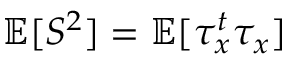Convert formula to latex. <formula><loc_0><loc_0><loc_500><loc_500>\mathbb { E } [ S ^ { 2 } ] = \mathbb { E } [ \tau _ { x } ^ { t } \tau _ { x } ]</formula> 